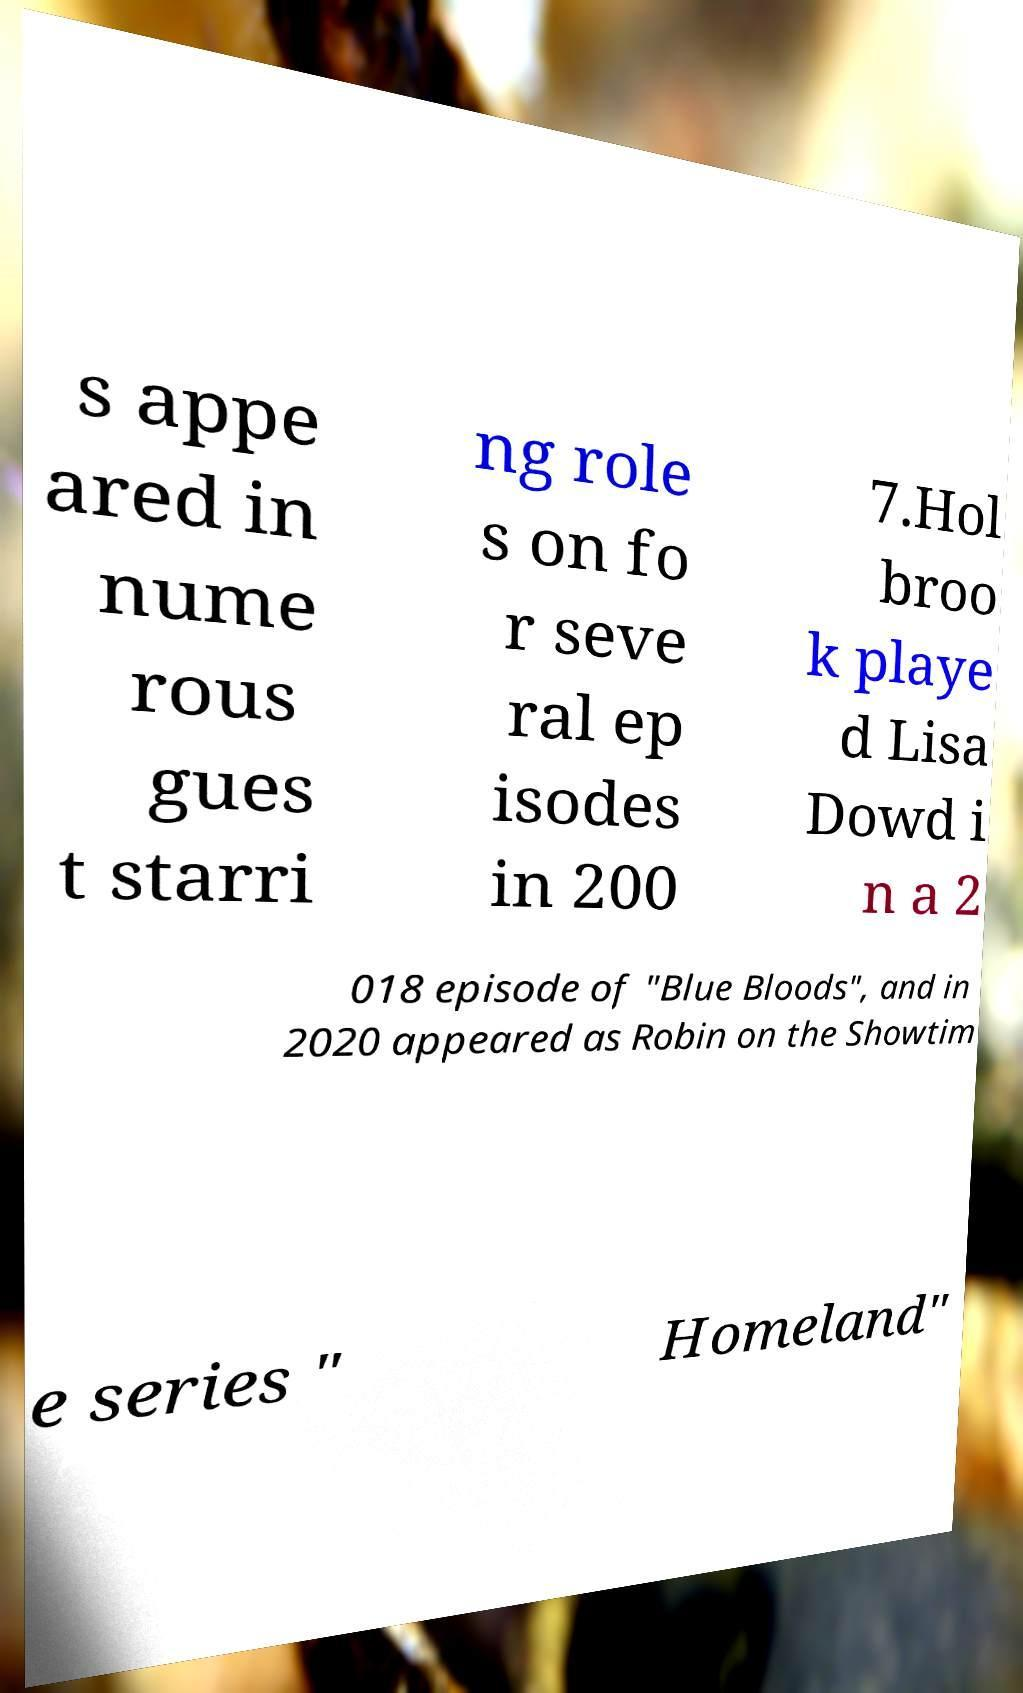There's text embedded in this image that I need extracted. Can you transcribe it verbatim? s appe ared in nume rous gues t starri ng role s on fo r seve ral ep isodes in 200 7.Hol broo k playe d Lisa Dowd i n a 2 018 episode of "Blue Bloods", and in 2020 appeared as Robin on the Showtim e series " Homeland" 